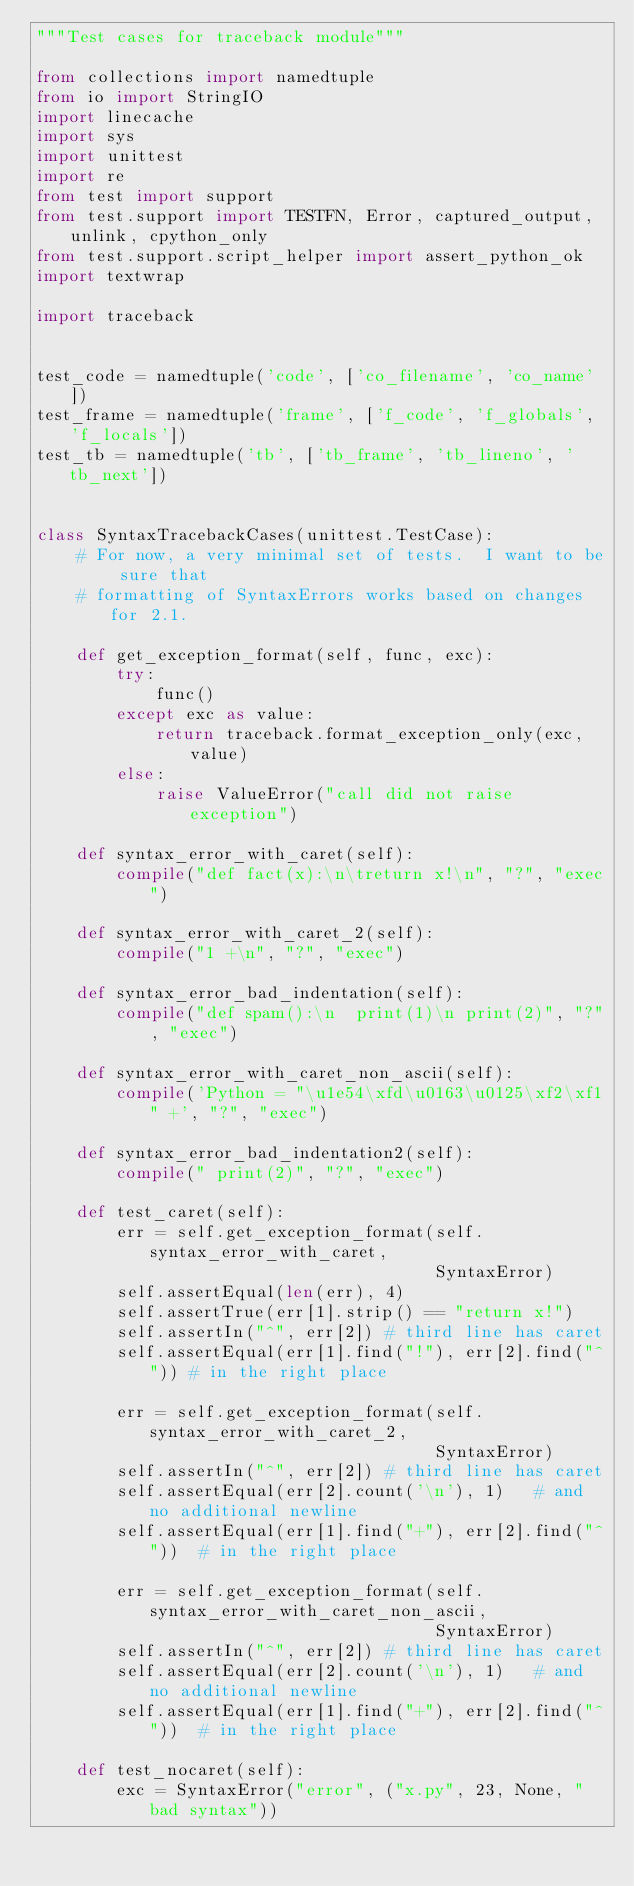Convert code to text. <code><loc_0><loc_0><loc_500><loc_500><_Python_>"""Test cases for traceback module"""

from collections import namedtuple
from io import StringIO
import linecache
import sys
import unittest
import re
from test import support
from test.support import TESTFN, Error, captured_output, unlink, cpython_only
from test.support.script_helper import assert_python_ok
import textwrap

import traceback


test_code = namedtuple('code', ['co_filename', 'co_name'])
test_frame = namedtuple('frame', ['f_code', 'f_globals', 'f_locals'])
test_tb = namedtuple('tb', ['tb_frame', 'tb_lineno', 'tb_next'])


class SyntaxTracebackCases(unittest.TestCase):
    # For now, a very minimal set of tests.  I want to be sure that
    # formatting of SyntaxErrors works based on changes for 2.1.

    def get_exception_format(self, func, exc):
        try:
            func()
        except exc as value:
            return traceback.format_exception_only(exc, value)
        else:
            raise ValueError("call did not raise exception")

    def syntax_error_with_caret(self):
        compile("def fact(x):\n\treturn x!\n", "?", "exec")

    def syntax_error_with_caret_2(self):
        compile("1 +\n", "?", "exec")

    def syntax_error_bad_indentation(self):
        compile("def spam():\n  print(1)\n print(2)", "?", "exec")

    def syntax_error_with_caret_non_ascii(self):
        compile('Python = "\u1e54\xfd\u0163\u0125\xf2\xf1" +', "?", "exec")

    def syntax_error_bad_indentation2(self):
        compile(" print(2)", "?", "exec")

    def test_caret(self):
        err = self.get_exception_format(self.syntax_error_with_caret,
                                        SyntaxError)
        self.assertEqual(len(err), 4)
        self.assertTrue(err[1].strip() == "return x!")
        self.assertIn("^", err[2]) # third line has caret
        self.assertEqual(err[1].find("!"), err[2].find("^")) # in the right place

        err = self.get_exception_format(self.syntax_error_with_caret_2,
                                        SyntaxError)
        self.assertIn("^", err[2]) # third line has caret
        self.assertEqual(err[2].count('\n'), 1)   # and no additional newline
        self.assertEqual(err[1].find("+"), err[2].find("^"))  # in the right place

        err = self.get_exception_format(self.syntax_error_with_caret_non_ascii,
                                        SyntaxError)
        self.assertIn("^", err[2]) # third line has caret
        self.assertEqual(err[2].count('\n'), 1)   # and no additional newline
        self.assertEqual(err[1].find("+"), err[2].find("^"))  # in the right place

    def test_nocaret(self):
        exc = SyntaxError("error", ("x.py", 23, None, "bad syntax"))</code> 